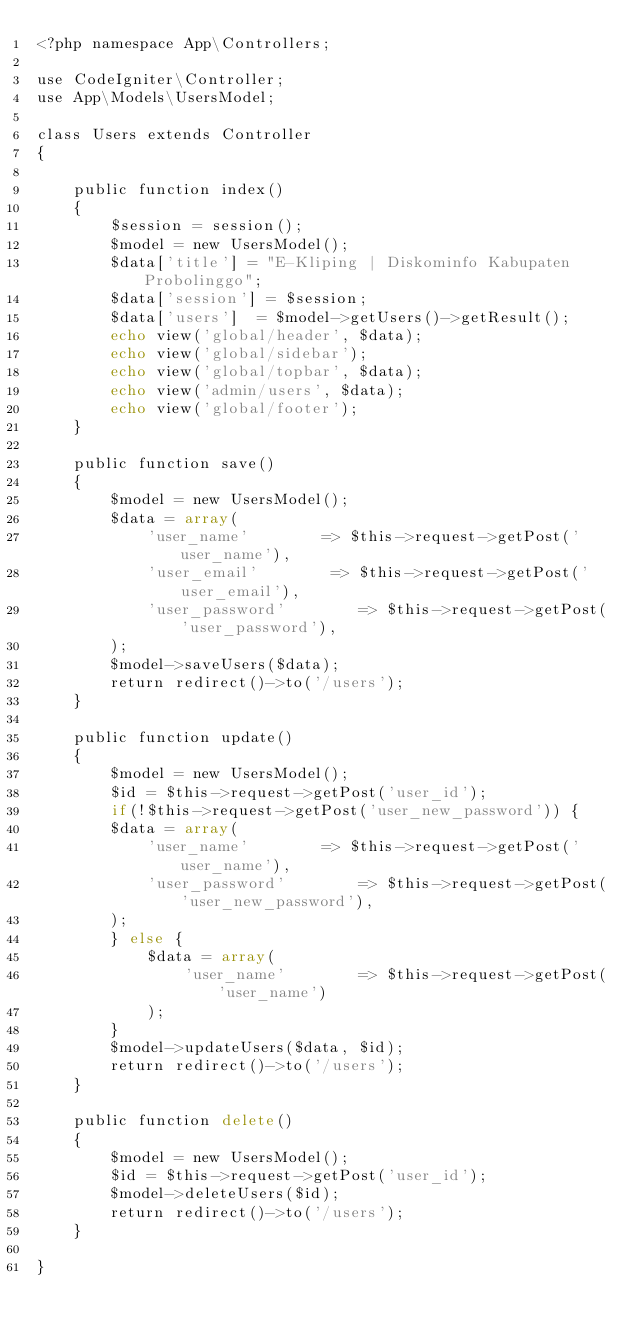Convert code to text. <code><loc_0><loc_0><loc_500><loc_500><_PHP_><?php namespace App\Controllers;

use CodeIgniter\Controller;
use App\Models\UsersModel;

class Users extends Controller
{

    public function index()
    {
        $session = session();
        $model = new UsersModel();
        $data['title'] = "E-Kliping | Diskominfo Kabupaten Probolinggo";
        $data['session'] = $session;
        $data['users']  = $model->getUsers()->getResult();
        echo view('global/header', $data);
        echo view('global/sidebar');
        echo view('global/topbar', $data);
        echo view('admin/users', $data);
        echo view('global/footer');
    }

    public function save()
    {
        $model = new UsersModel();
        $data = array(
            'user_name'        => $this->request->getPost('user_name'),
            'user_email'        => $this->request->getPost('user_email'),
            'user_password'        => $this->request->getPost('user_password'),
        );
        $model->saveUsers($data);
        return redirect()->to('/users');
    }

    public function update()
    {
        $model = new UsersModel();
        $id = $this->request->getPost('user_id');
        if(!$this->request->getPost('user_new_password')) {
        $data = array(
            'user_name'        => $this->request->getPost('user_name'),
            'user_password'        => $this->request->getPost('user_new_password'),
        );
        } else {
            $data = array(
                'user_name'        => $this->request->getPost('user_name')
            );
        }
        $model->updateUsers($data, $id);
        return redirect()->to('/users');
    }

    public function delete()
    {
        $model = new UsersModel();
        $id = $this->request->getPost('user_id');
        $model->deleteUsers($id);
        return redirect()->to('/users');
    }

}</code> 